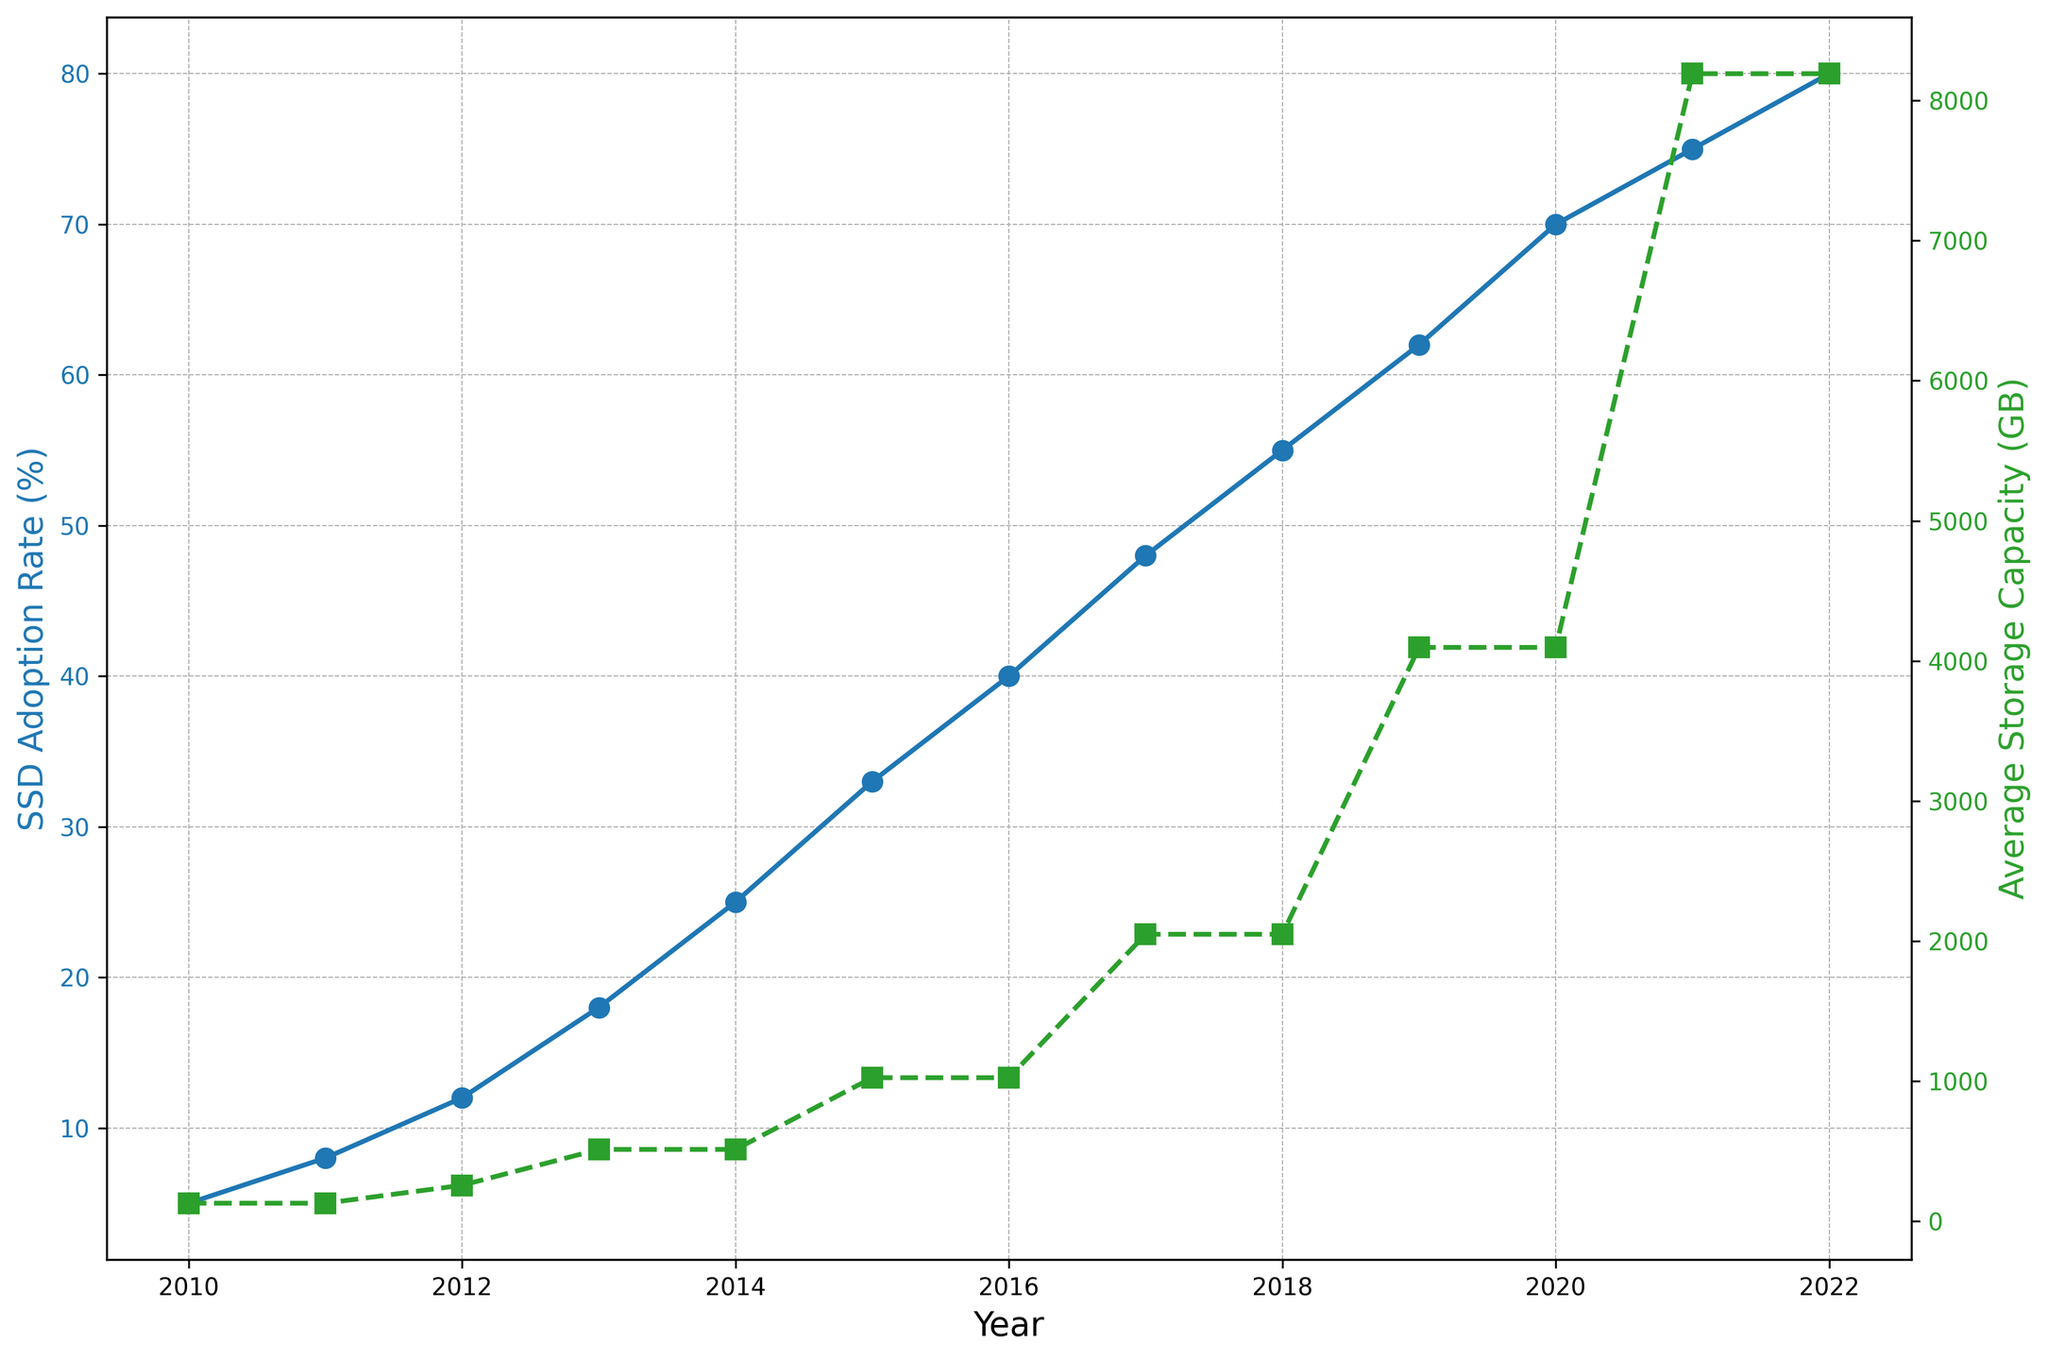What year did the SSD Adoption Rate first reach 30%? Examine the blue line that represents the SSD Adoption Rate. Look for the point at which the value first meets or exceeds 30%. This occurs in the year 2015.
Answer: 2015 In what year did the Average Storage Capacity double for the first time from its previous value? Follow the green line representing the Average Storage Capacity. Identify the year when the first doubling of the value occurs. In 2013, the value is 512GB, which is double of the previous year's 256GB (2012).
Answer: 2013 Which increased more sharply between 2017 and 2019, SSD Adoption Rate or Average Storage Capacity? Calculate the increase for both metrics between 2017 and 2019. SSD Adoption Rate went from 48% to 62%, an increase of 14%. Average Storage Capacity went from 2048GB to 4096GB, an increase of 2048GB. The sharper relative increase is for SSD Adoption Rate at 14%, while the absolute increase for Average Storage Capacity is 2048GB. Depending on the context of "sharply," both could be seen as correct, but the relative percentage is clearer with SSD Adoption Rate.
Answer: SSD Adoption Rate What is the visual difference in line styles between SSD Adoption Rate and Average Storage Capacity? Observe both lines: The blue line for SSD Adoption Rate is a solid line with circle markers. The green line for Average Storage Capacity is a dashed line with square markers.
Answer: SSD Adoption Rate: solid line with circles, Average Storage Capacity: dashed line with squares Between 2010 and 2022, in which years did both SSD Adoption Rate and Average Storage Capacity increase at the same time? Check both lines for simultaneous increase years. Both metrics increase every year from 2010 to 2022.
Answer: 2010 to 2022 In what year did the Average Storage Capacity first exceed 1TB? Look for the first year when the green line representing Average Storage Capacity surpassed 1024GB (1TB). This happens in 2017.
Answer: 2017 By how much did Average Storage Capacity increase from 2013 to 2019? Subtract the Average Storage Capacity value in 2013 from that in 2019. The storage capacity increased from 512GB (2013) to 4096GB (2019). So, 4096GB - 512GB = 3584GB.
Answer: 3584GB Which year had a greater increase in SSD Adoption Rate, 2015-2016 or 2017-2018? Calculate the increase for both periods: 2015-2016 is 40% - 33% = 7%, and 2017-2018 is 55% - 48% = 7%. Both periods show the same increase.
Answer: Both periods had the same increase of 7% By what percentage did SSD Adoption Rate increase from 2018 to 2022? Calculate the percentage increase from 2018 (55%) to 2022 (80%). Use the formula ((new value - old value)/old value) * 100 = ((80 - 55) / 55) * 100 = 45.45%.
Answer: 45.45% What is the visual trend of the green line from 2010 to 2022? The green line, representing Average Storage Capacity, shows an upward trend with increasing values each year, indicating that average storage capacity has consistently risen.
Answer: Upward trend 